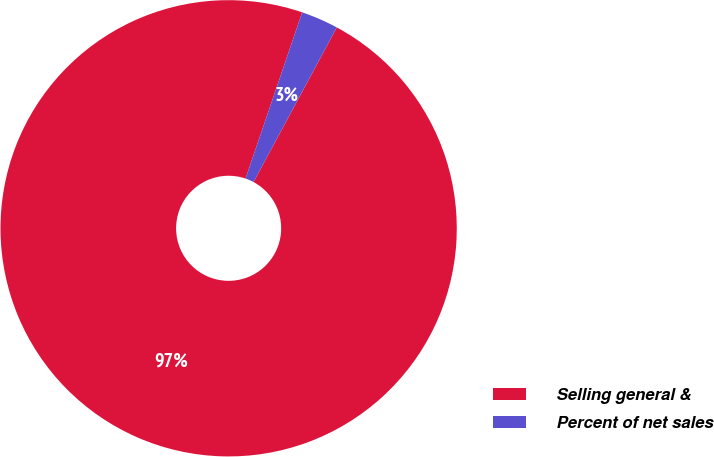Convert chart to OTSL. <chart><loc_0><loc_0><loc_500><loc_500><pie_chart><fcel>Selling general &<fcel>Percent of net sales<nl><fcel>97.36%<fcel>2.64%<nl></chart> 